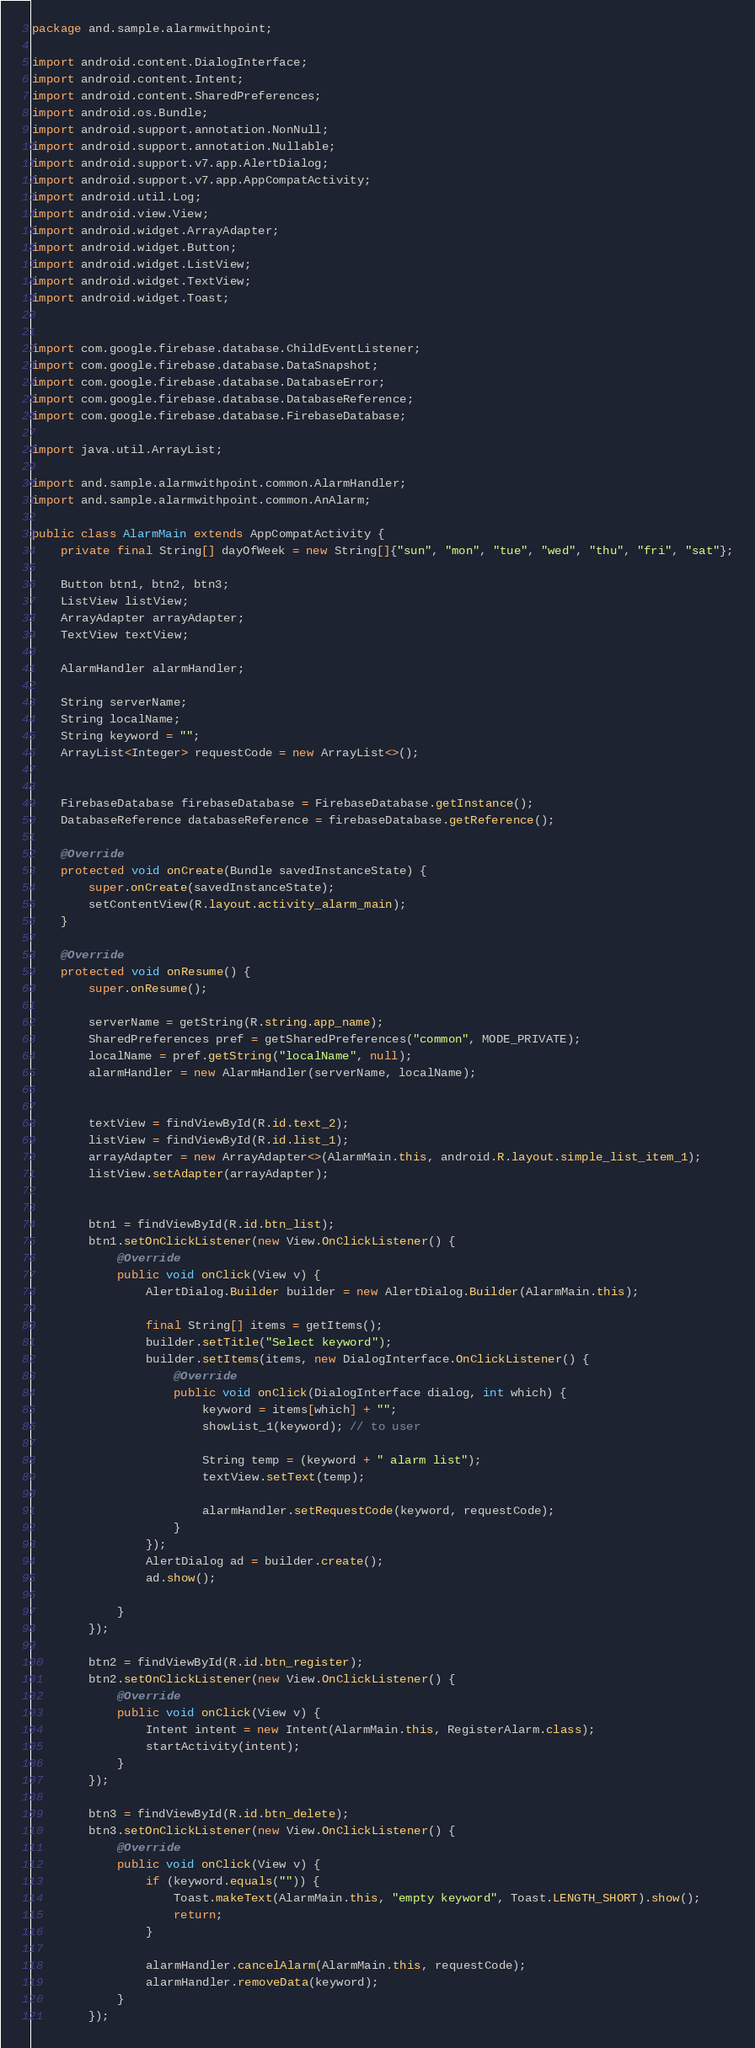<code> <loc_0><loc_0><loc_500><loc_500><_Java_>package and.sample.alarmwithpoint;

import android.content.DialogInterface;
import android.content.Intent;
import android.content.SharedPreferences;
import android.os.Bundle;
import android.support.annotation.NonNull;
import android.support.annotation.Nullable;
import android.support.v7.app.AlertDialog;
import android.support.v7.app.AppCompatActivity;
import android.util.Log;
import android.view.View;
import android.widget.ArrayAdapter;
import android.widget.Button;
import android.widget.ListView;
import android.widget.TextView;
import android.widget.Toast;


import com.google.firebase.database.ChildEventListener;
import com.google.firebase.database.DataSnapshot;
import com.google.firebase.database.DatabaseError;
import com.google.firebase.database.DatabaseReference;
import com.google.firebase.database.FirebaseDatabase;

import java.util.ArrayList;

import and.sample.alarmwithpoint.common.AlarmHandler;
import and.sample.alarmwithpoint.common.AnAlarm;

public class AlarmMain extends AppCompatActivity {
    private final String[] dayOfWeek = new String[]{"sun", "mon", "tue", "wed", "thu", "fri", "sat"};

    Button btn1, btn2, btn3;
    ListView listView;
    ArrayAdapter arrayAdapter;
    TextView textView;

    AlarmHandler alarmHandler;

    String serverName;
    String localName;
    String keyword = "";
    ArrayList<Integer> requestCode = new ArrayList<>();


    FirebaseDatabase firebaseDatabase = FirebaseDatabase.getInstance();
    DatabaseReference databaseReference = firebaseDatabase.getReference();

    @Override
    protected void onCreate(Bundle savedInstanceState) {
        super.onCreate(savedInstanceState);
        setContentView(R.layout.activity_alarm_main);
    }

    @Override
    protected void onResume() {
        super.onResume();

        serverName = getString(R.string.app_name);
        SharedPreferences pref = getSharedPreferences("common", MODE_PRIVATE);
        localName = pref.getString("localName", null);
        alarmHandler = new AlarmHandler(serverName, localName);


        textView = findViewById(R.id.text_2);
        listView = findViewById(R.id.list_1);
        arrayAdapter = new ArrayAdapter<>(AlarmMain.this, android.R.layout.simple_list_item_1);
        listView.setAdapter(arrayAdapter);


        btn1 = findViewById(R.id.btn_list);
        btn1.setOnClickListener(new View.OnClickListener() {
            @Override
            public void onClick(View v) {
                AlertDialog.Builder builder = new AlertDialog.Builder(AlarmMain.this);

                final String[] items = getItems();
                builder.setTitle("Select keyword");
                builder.setItems(items, new DialogInterface.OnClickListener() {
                    @Override
                    public void onClick(DialogInterface dialog, int which) {
                        keyword = items[which] + "";
                        showList_1(keyword); // to user

                        String temp = (keyword + " alarm list");
                        textView.setText(temp);

                        alarmHandler.setRequestCode(keyword, requestCode);
                    }
                });
                AlertDialog ad = builder.create();
                ad.show();

            }
        });

        btn2 = findViewById(R.id.btn_register);
        btn2.setOnClickListener(new View.OnClickListener() {
            @Override
            public void onClick(View v) {
                Intent intent = new Intent(AlarmMain.this, RegisterAlarm.class);
                startActivity(intent);
            }
        });

        btn3 = findViewById(R.id.btn_delete);
        btn3.setOnClickListener(new View.OnClickListener() {
            @Override
            public void onClick(View v) {
                if (keyword.equals("")) {
                    Toast.makeText(AlarmMain.this, "empty keyword", Toast.LENGTH_SHORT).show();
                    return;
                }

                alarmHandler.cancelAlarm(AlarmMain.this, requestCode);
                alarmHandler.removeData(keyword);
            }
        });</code> 